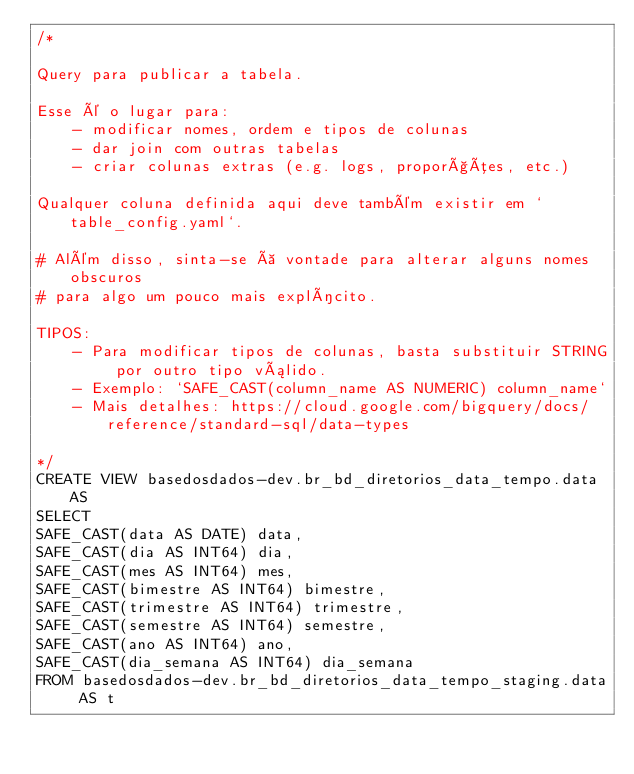Convert code to text. <code><loc_0><loc_0><loc_500><loc_500><_SQL_>/*

Query para publicar a tabela.

Esse é o lugar para:
    - modificar nomes, ordem e tipos de colunas
    - dar join com outras tabelas
    - criar colunas extras (e.g. logs, proporções, etc.)

Qualquer coluna definida aqui deve também existir em `table_config.yaml`.

# Além disso, sinta-se à vontade para alterar alguns nomes obscuros
# para algo um pouco mais explícito.

TIPOS:
    - Para modificar tipos de colunas, basta substituir STRING por outro tipo válido.
    - Exemplo: `SAFE_CAST(column_name AS NUMERIC) column_name`
    - Mais detalhes: https://cloud.google.com/bigquery/docs/reference/standard-sql/data-types

*/
CREATE VIEW basedosdados-dev.br_bd_diretorios_data_tempo.data AS
SELECT 
SAFE_CAST(data AS DATE) data,
SAFE_CAST(dia AS INT64) dia,
SAFE_CAST(mes AS INT64) mes,
SAFE_CAST(bimestre AS INT64) bimestre,
SAFE_CAST(trimestre AS INT64) trimestre,
SAFE_CAST(semestre AS INT64) semestre,
SAFE_CAST(ano AS INT64) ano,
SAFE_CAST(dia_semana AS INT64) dia_semana
FROM basedosdados-dev.br_bd_diretorios_data_tempo_staging.data AS t</code> 